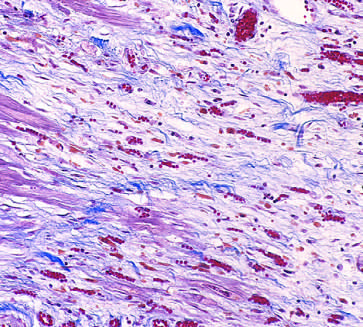s this tumor characterized by loose connective tissue and abundant capillaries?
Answer the question using a single word or phrase. No 